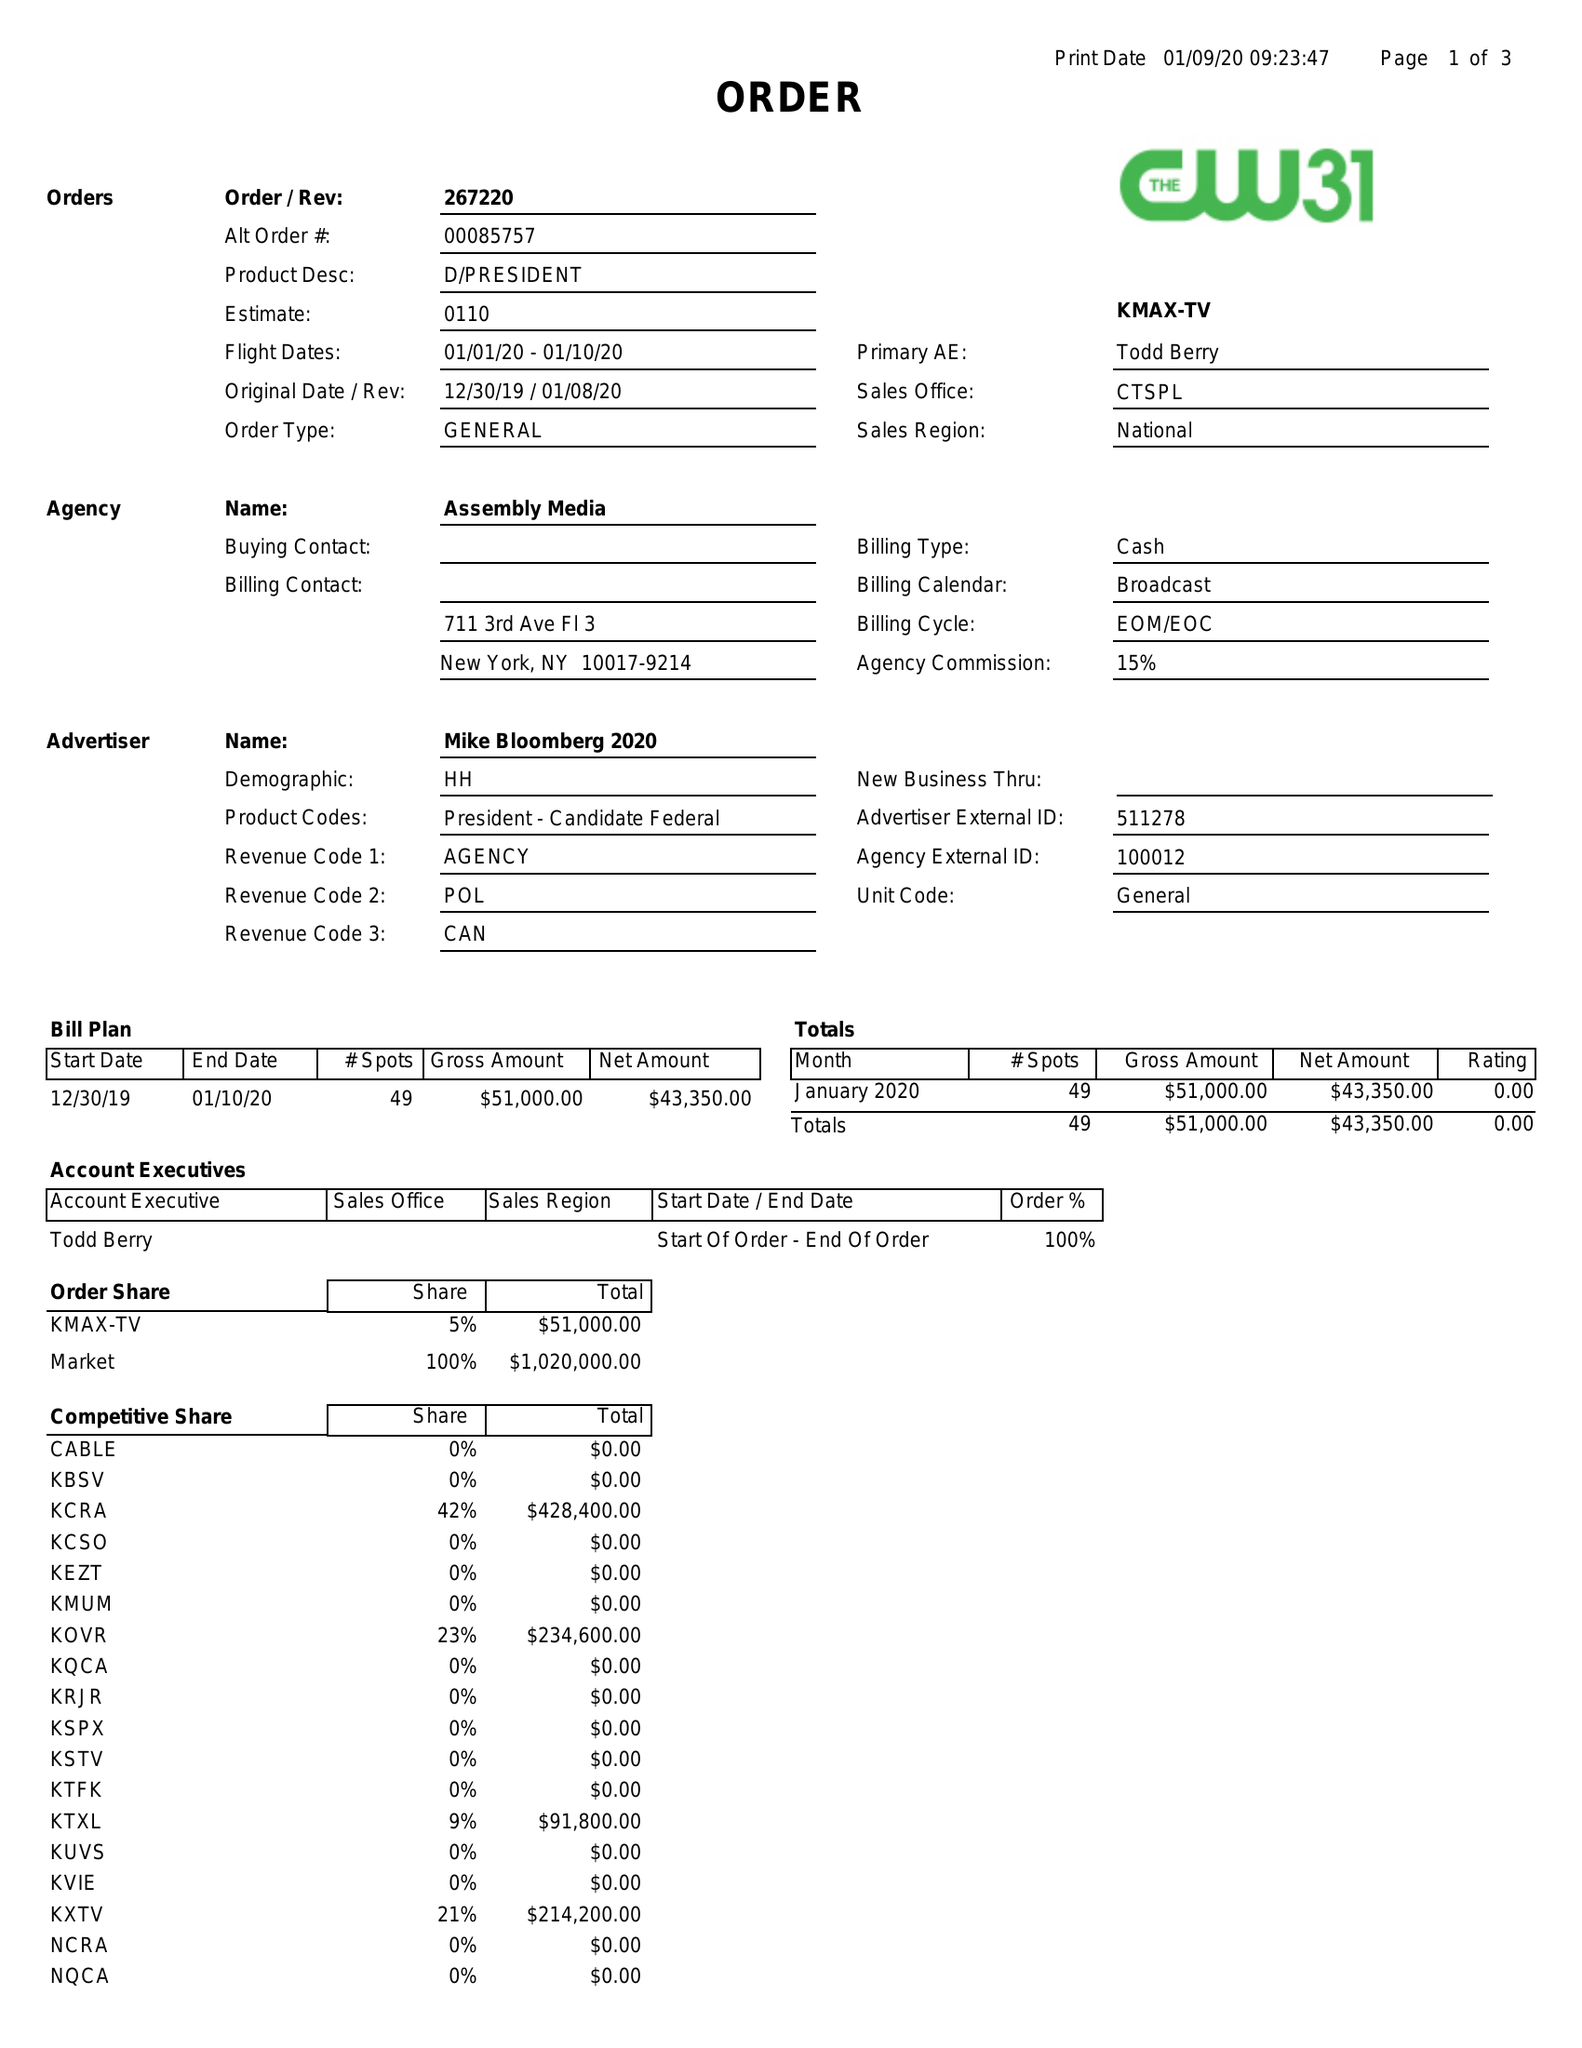What is the value for the flight_from?
Answer the question using a single word or phrase. 01/01/20 